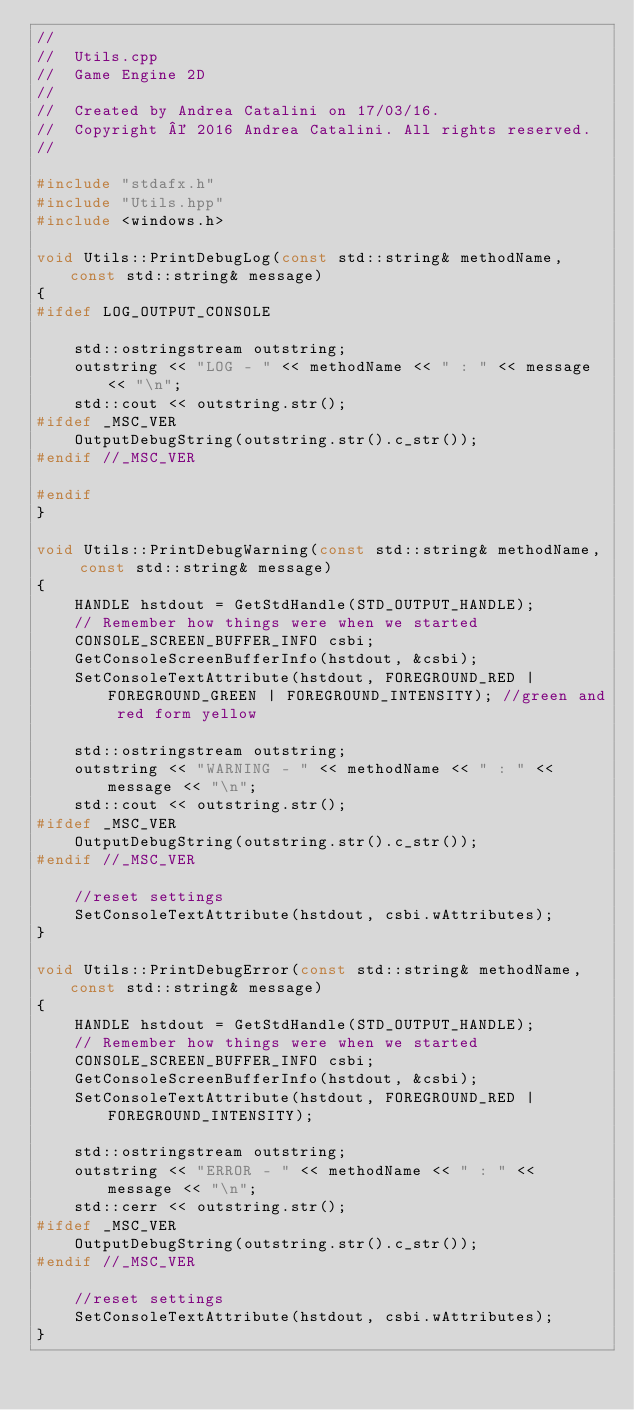Convert code to text. <code><loc_0><loc_0><loc_500><loc_500><_C++_>//
//  Utils.cpp
//  Game Engine 2D
//
//  Created by Andrea Catalini on 17/03/16.
//  Copyright © 2016 Andrea Catalini. All rights reserved.
//

#include "stdafx.h"
#include "Utils.hpp"
#include <windows.h>

void Utils::PrintDebugLog(const std::string& methodName, const std::string& message)
{
#ifdef LOG_OUTPUT_CONSOLE

	std::ostringstream outstring;
	outstring << "LOG - " << methodName << " : " << message << "\n";
    std::cout << outstring.str();
#ifdef _MSC_VER
	OutputDebugString(outstring.str().c_str());
#endif //_MSC_VER

#endif
}

void Utils::PrintDebugWarning(const std::string& methodName, const std::string& message)
{
	HANDLE hstdout = GetStdHandle(STD_OUTPUT_HANDLE);
	// Remember how things were when we started
	CONSOLE_SCREEN_BUFFER_INFO csbi;
	GetConsoleScreenBufferInfo(hstdout, &csbi);
	SetConsoleTextAttribute(hstdout, FOREGROUND_RED | FOREGROUND_GREEN | FOREGROUND_INTENSITY); //green and red form yellow

	std::ostringstream outstring;
	outstring << "WARNING - " << methodName << " : " << message << "\n";
    std::cout << outstring.str();
#ifdef _MSC_VER
	OutputDebugString(outstring.str().c_str());
#endif //_MSC_VER

	//reset settings
	SetConsoleTextAttribute(hstdout, csbi.wAttributes);
}

void Utils::PrintDebugError(const std::string& methodName, const std::string& message)
{
	HANDLE hstdout = GetStdHandle(STD_OUTPUT_HANDLE);
	// Remember how things were when we started
	CONSOLE_SCREEN_BUFFER_INFO csbi;
	GetConsoleScreenBufferInfo(hstdout, &csbi);
	SetConsoleTextAttribute(hstdout, FOREGROUND_RED | FOREGROUND_INTENSITY);

	std::ostringstream outstring;
	outstring << "ERROR - " << methodName << " : " << message << "\n";
    std::cerr << outstring.str();
#ifdef _MSC_VER
	OutputDebugString(outstring.str().c_str());
#endif //_MSC_VER

	//reset settings
	SetConsoleTextAttribute(hstdout, csbi.wAttributes);
}
</code> 